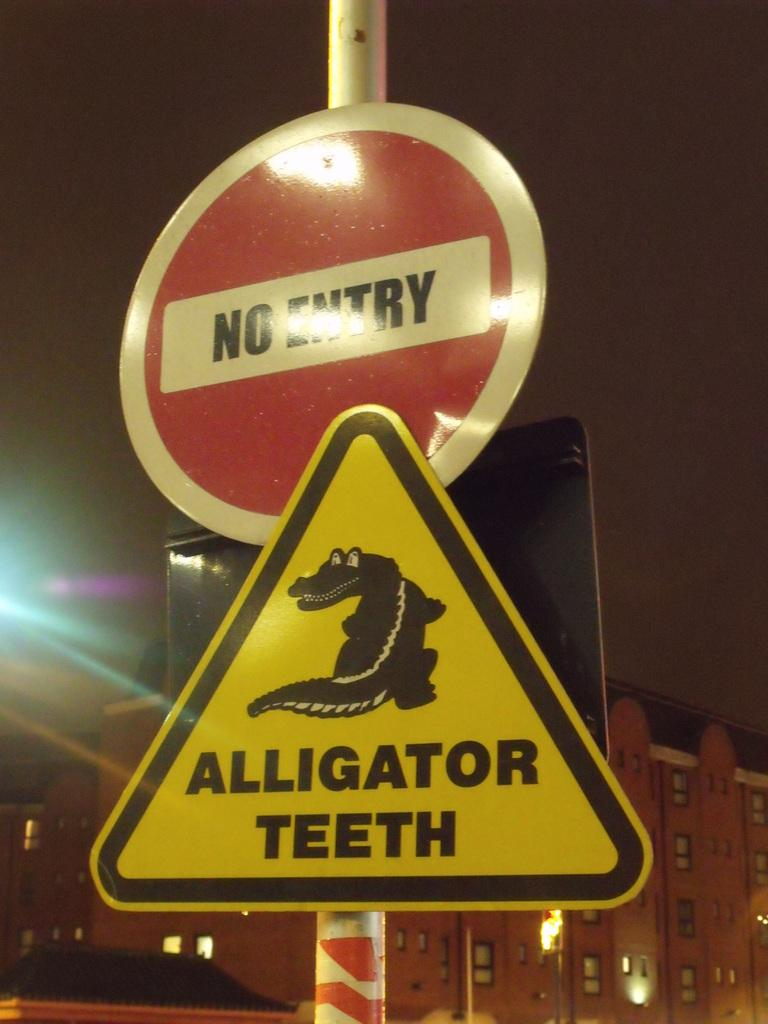<image>
Create a compact narrative representing the image presented. A "no entry" sign is above another yellow sign saying "alligator teeth". 